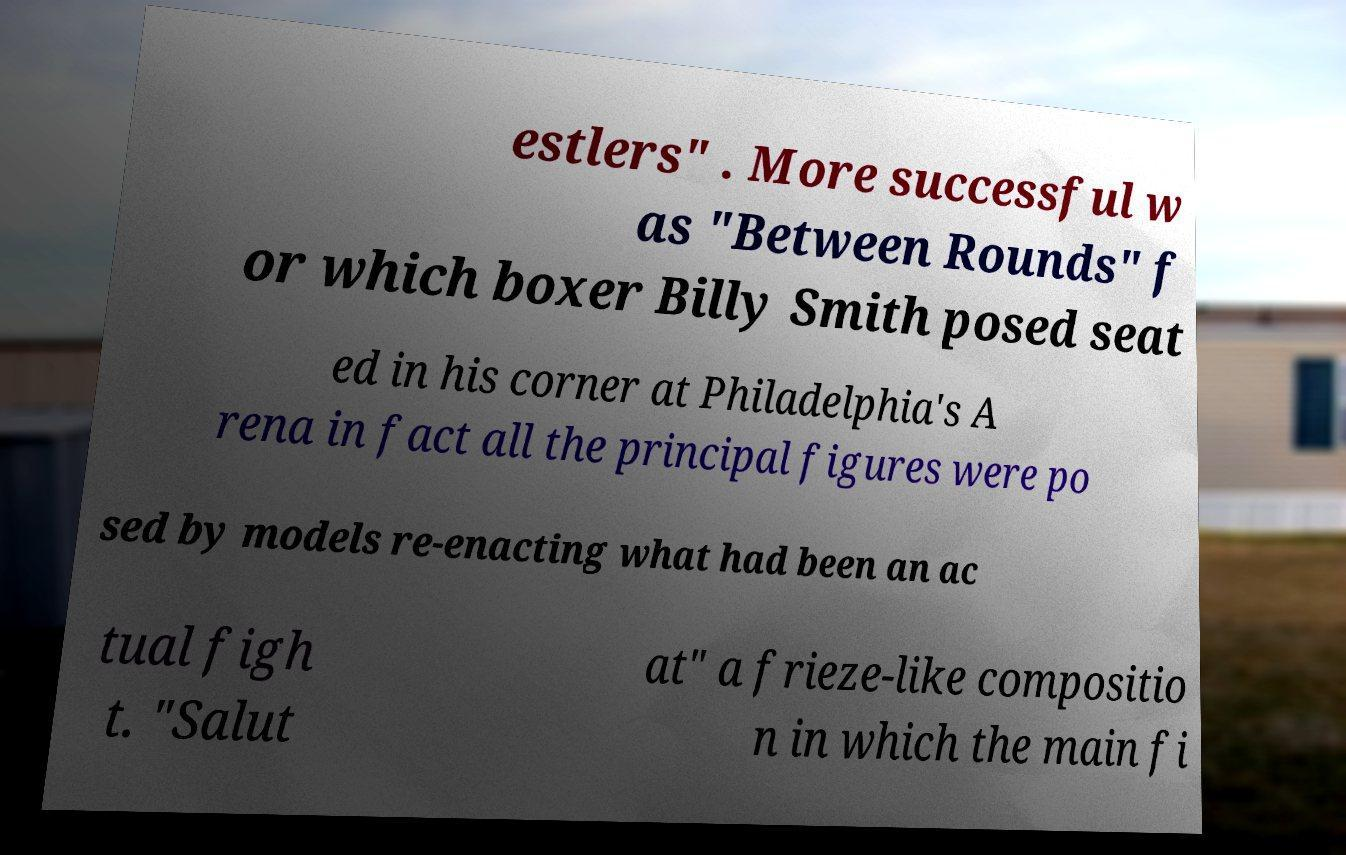Please identify and transcribe the text found in this image. estlers" . More successful w as "Between Rounds" f or which boxer Billy Smith posed seat ed in his corner at Philadelphia's A rena in fact all the principal figures were po sed by models re-enacting what had been an ac tual figh t. "Salut at" a frieze-like compositio n in which the main fi 